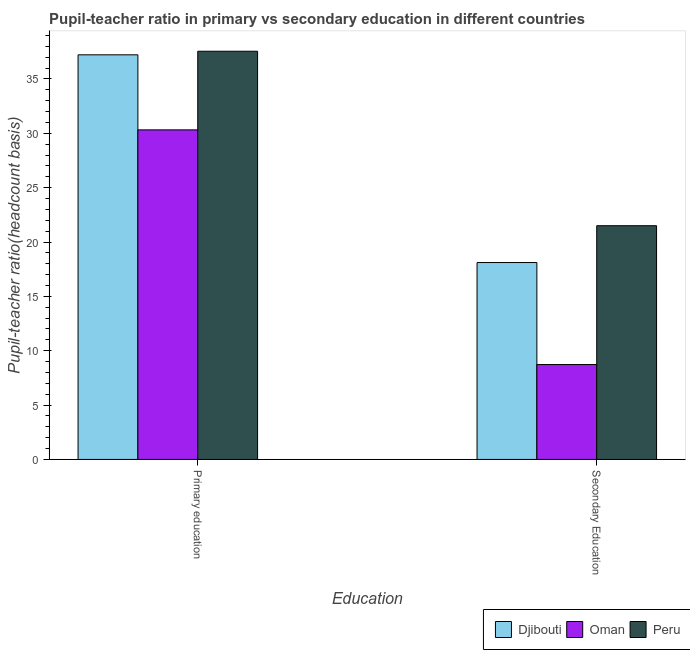How many groups of bars are there?
Offer a very short reply. 2. Are the number of bars per tick equal to the number of legend labels?
Provide a succinct answer. Yes. Are the number of bars on each tick of the X-axis equal?
Provide a succinct answer. Yes. How many bars are there on the 1st tick from the right?
Provide a succinct answer. 3. What is the label of the 2nd group of bars from the left?
Provide a short and direct response. Secondary Education. What is the pupil teacher ratio on secondary education in Djibouti?
Ensure brevity in your answer.  18.11. Across all countries, what is the maximum pupil teacher ratio on secondary education?
Your response must be concise. 21.5. Across all countries, what is the minimum pupil teacher ratio on secondary education?
Keep it short and to the point. 8.73. In which country was the pupil teacher ratio on secondary education maximum?
Ensure brevity in your answer.  Peru. In which country was the pupil-teacher ratio in primary education minimum?
Provide a short and direct response. Oman. What is the total pupil-teacher ratio in primary education in the graph?
Make the answer very short. 105.09. What is the difference between the pupil-teacher ratio in primary education in Peru and that in Djibouti?
Ensure brevity in your answer.  0.33. What is the difference between the pupil teacher ratio on secondary education in Oman and the pupil-teacher ratio in primary education in Peru?
Give a very brief answer. -28.82. What is the average pupil-teacher ratio in primary education per country?
Your answer should be very brief. 35.03. What is the difference between the pupil teacher ratio on secondary education and pupil-teacher ratio in primary education in Oman?
Make the answer very short. -21.59. What is the ratio of the pupil teacher ratio on secondary education in Djibouti to that in Oman?
Your answer should be compact. 2.08. In how many countries, is the pupil teacher ratio on secondary education greater than the average pupil teacher ratio on secondary education taken over all countries?
Provide a succinct answer. 2. What does the 1st bar from the left in Secondary Education represents?
Ensure brevity in your answer.  Djibouti. What does the 1st bar from the right in Primary education represents?
Offer a terse response. Peru. How many bars are there?
Your answer should be very brief. 6. Are all the bars in the graph horizontal?
Keep it short and to the point. No. What is the difference between two consecutive major ticks on the Y-axis?
Your answer should be very brief. 5. Does the graph contain any zero values?
Keep it short and to the point. No. How are the legend labels stacked?
Provide a succinct answer. Horizontal. What is the title of the graph?
Your answer should be very brief. Pupil-teacher ratio in primary vs secondary education in different countries. Does "Lithuania" appear as one of the legend labels in the graph?
Offer a very short reply. No. What is the label or title of the X-axis?
Provide a short and direct response. Education. What is the label or title of the Y-axis?
Your answer should be compact. Pupil-teacher ratio(headcount basis). What is the Pupil-teacher ratio(headcount basis) in Djibouti in Primary education?
Keep it short and to the point. 37.22. What is the Pupil-teacher ratio(headcount basis) in Oman in Primary education?
Provide a short and direct response. 30.32. What is the Pupil-teacher ratio(headcount basis) of Peru in Primary education?
Ensure brevity in your answer.  37.55. What is the Pupil-teacher ratio(headcount basis) of Djibouti in Secondary Education?
Your answer should be compact. 18.11. What is the Pupil-teacher ratio(headcount basis) of Oman in Secondary Education?
Provide a short and direct response. 8.73. What is the Pupil-teacher ratio(headcount basis) of Peru in Secondary Education?
Make the answer very short. 21.5. Across all Education, what is the maximum Pupil-teacher ratio(headcount basis) in Djibouti?
Offer a very short reply. 37.22. Across all Education, what is the maximum Pupil-teacher ratio(headcount basis) of Oman?
Make the answer very short. 30.32. Across all Education, what is the maximum Pupil-teacher ratio(headcount basis) in Peru?
Keep it short and to the point. 37.55. Across all Education, what is the minimum Pupil-teacher ratio(headcount basis) of Djibouti?
Offer a terse response. 18.11. Across all Education, what is the minimum Pupil-teacher ratio(headcount basis) of Oman?
Provide a short and direct response. 8.73. Across all Education, what is the minimum Pupil-teacher ratio(headcount basis) in Peru?
Keep it short and to the point. 21.5. What is the total Pupil-teacher ratio(headcount basis) in Djibouti in the graph?
Keep it short and to the point. 55.34. What is the total Pupil-teacher ratio(headcount basis) in Oman in the graph?
Provide a succinct answer. 39.05. What is the total Pupil-teacher ratio(headcount basis) in Peru in the graph?
Offer a terse response. 59.05. What is the difference between the Pupil-teacher ratio(headcount basis) of Djibouti in Primary education and that in Secondary Education?
Make the answer very short. 19.11. What is the difference between the Pupil-teacher ratio(headcount basis) of Oman in Primary education and that in Secondary Education?
Your answer should be compact. 21.59. What is the difference between the Pupil-teacher ratio(headcount basis) in Peru in Primary education and that in Secondary Education?
Provide a short and direct response. 16.05. What is the difference between the Pupil-teacher ratio(headcount basis) of Djibouti in Primary education and the Pupil-teacher ratio(headcount basis) of Oman in Secondary Education?
Give a very brief answer. 28.49. What is the difference between the Pupil-teacher ratio(headcount basis) of Djibouti in Primary education and the Pupil-teacher ratio(headcount basis) of Peru in Secondary Education?
Your response must be concise. 15.72. What is the difference between the Pupil-teacher ratio(headcount basis) of Oman in Primary education and the Pupil-teacher ratio(headcount basis) of Peru in Secondary Education?
Offer a terse response. 8.82. What is the average Pupil-teacher ratio(headcount basis) of Djibouti per Education?
Your answer should be compact. 27.67. What is the average Pupil-teacher ratio(headcount basis) of Oman per Education?
Give a very brief answer. 19.52. What is the average Pupil-teacher ratio(headcount basis) of Peru per Education?
Keep it short and to the point. 29.53. What is the difference between the Pupil-teacher ratio(headcount basis) of Djibouti and Pupil-teacher ratio(headcount basis) of Oman in Primary education?
Offer a terse response. 6.9. What is the difference between the Pupil-teacher ratio(headcount basis) in Djibouti and Pupil-teacher ratio(headcount basis) in Peru in Primary education?
Keep it short and to the point. -0.33. What is the difference between the Pupil-teacher ratio(headcount basis) of Oman and Pupil-teacher ratio(headcount basis) of Peru in Primary education?
Ensure brevity in your answer.  -7.23. What is the difference between the Pupil-teacher ratio(headcount basis) in Djibouti and Pupil-teacher ratio(headcount basis) in Oman in Secondary Education?
Your answer should be compact. 9.38. What is the difference between the Pupil-teacher ratio(headcount basis) of Djibouti and Pupil-teacher ratio(headcount basis) of Peru in Secondary Education?
Make the answer very short. -3.39. What is the difference between the Pupil-teacher ratio(headcount basis) in Oman and Pupil-teacher ratio(headcount basis) in Peru in Secondary Education?
Offer a very short reply. -12.77. What is the ratio of the Pupil-teacher ratio(headcount basis) of Djibouti in Primary education to that in Secondary Education?
Provide a succinct answer. 2.06. What is the ratio of the Pupil-teacher ratio(headcount basis) in Oman in Primary education to that in Secondary Education?
Provide a short and direct response. 3.47. What is the ratio of the Pupil-teacher ratio(headcount basis) of Peru in Primary education to that in Secondary Education?
Offer a terse response. 1.75. What is the difference between the highest and the second highest Pupil-teacher ratio(headcount basis) in Djibouti?
Keep it short and to the point. 19.11. What is the difference between the highest and the second highest Pupil-teacher ratio(headcount basis) of Oman?
Your answer should be compact. 21.59. What is the difference between the highest and the second highest Pupil-teacher ratio(headcount basis) in Peru?
Keep it short and to the point. 16.05. What is the difference between the highest and the lowest Pupil-teacher ratio(headcount basis) in Djibouti?
Keep it short and to the point. 19.11. What is the difference between the highest and the lowest Pupil-teacher ratio(headcount basis) of Oman?
Ensure brevity in your answer.  21.59. What is the difference between the highest and the lowest Pupil-teacher ratio(headcount basis) of Peru?
Offer a very short reply. 16.05. 